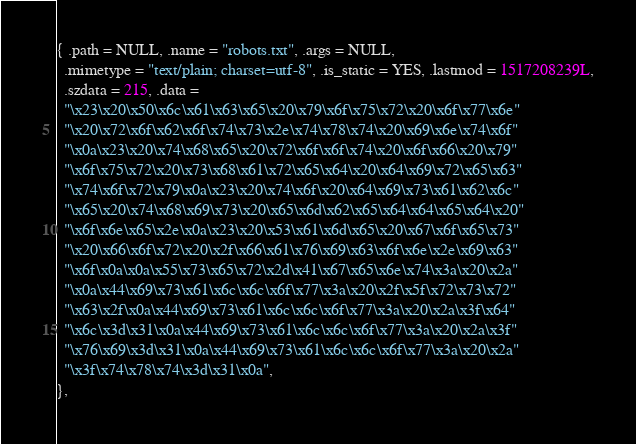Convert code to text. <code><loc_0><loc_0><loc_500><loc_500><_C_>{ .path = NULL, .name = "robots.txt", .args = NULL,
  .mimetype = "text/plain; charset=utf-8", .is_static = YES, .lastmod = 1517208239L,
  .szdata = 215, .data =
  "\x23\x20\x50\x6c\x61\x63\x65\x20\x79\x6f\x75\x72\x20\x6f\x77\x6e"
  "\x20\x72\x6f\x62\x6f\x74\x73\x2e\x74\x78\x74\x20\x69\x6e\x74\x6f"
  "\x0a\x23\x20\x74\x68\x65\x20\x72\x6f\x6f\x74\x20\x6f\x66\x20\x79"
  "\x6f\x75\x72\x20\x73\x68\x61\x72\x65\x64\x20\x64\x69\x72\x65\x63"
  "\x74\x6f\x72\x79\x0a\x23\x20\x74\x6f\x20\x64\x69\x73\x61\x62\x6c"
  "\x65\x20\x74\x68\x69\x73\x20\x65\x6d\x62\x65\x64\x64\x65\x64\x20"
  "\x6f\x6e\x65\x2e\x0a\x23\x20\x53\x61\x6d\x65\x20\x67\x6f\x65\x73"
  "\x20\x66\x6f\x72\x20\x2f\x66\x61\x76\x69\x63\x6f\x6e\x2e\x69\x63"
  "\x6f\x0a\x0a\x55\x73\x65\x72\x2d\x41\x67\x65\x6e\x74\x3a\x20\x2a"
  "\x0a\x44\x69\x73\x61\x6c\x6c\x6f\x77\x3a\x20\x2f\x5f\x72\x73\x72"
  "\x63\x2f\x0a\x44\x69\x73\x61\x6c\x6c\x6f\x77\x3a\x20\x2a\x3f\x64"
  "\x6c\x3d\x31\x0a\x44\x69\x73\x61\x6c\x6c\x6f\x77\x3a\x20\x2a\x3f"
  "\x76\x69\x3d\x31\x0a\x44\x69\x73\x61\x6c\x6c\x6f\x77\x3a\x20\x2a"
  "\x3f\x74\x78\x74\x3d\x31\x0a",
},
</code> 